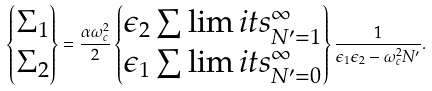Convert formula to latex. <formula><loc_0><loc_0><loc_500><loc_500>\begin{Bmatrix} \Sigma _ { 1 } \\ \Sigma _ { 2 } \end{Bmatrix} = \frac { \alpha \omega _ { c } ^ { 2 } } { 2 } \begin{Bmatrix} \epsilon _ { 2 } \sum \lim i t s _ { N ^ { \prime } = 1 } ^ { \infty } \\ \epsilon _ { 1 } \sum \lim i t s _ { N ^ { \prime } = 0 } ^ { \infty } \end{Bmatrix} \frac { 1 } { \epsilon _ { 1 } \epsilon _ { 2 } - \omega _ { c } ^ { 2 } N ^ { \prime } } .</formula> 